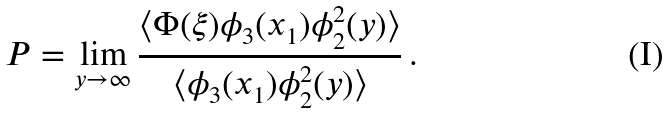Convert formula to latex. <formula><loc_0><loc_0><loc_500><loc_500>P = \lim _ { y \rightarrow \infty } \frac { \langle \Phi ( \xi ) \phi _ { 3 } ( x _ { 1 } ) \phi _ { 2 } ^ { 2 } ( y ) \rangle } { \langle \phi _ { 3 } ( x _ { 1 } ) \phi _ { 2 } ^ { 2 } ( y ) \rangle } \, .</formula> 